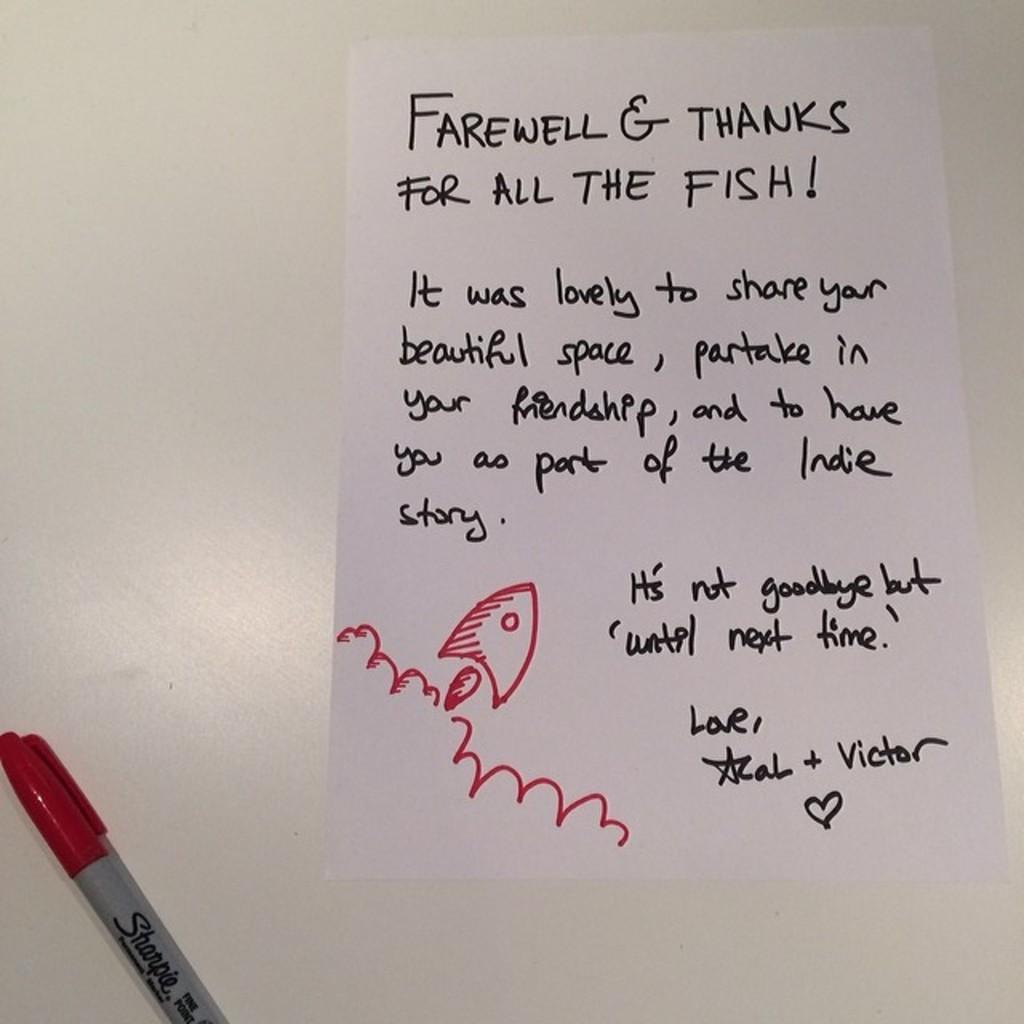What is written on the paper in the image? The provided facts do not specify the content of the text on the paper. What object is used for writing in the image? There is a pen in the image. On what surface is the pen placed? The pen is on a white surface. How many sheep are visible in the image? There are no sheep present in the image. What type of band is playing in the background of the image? There is no band present in the image. 